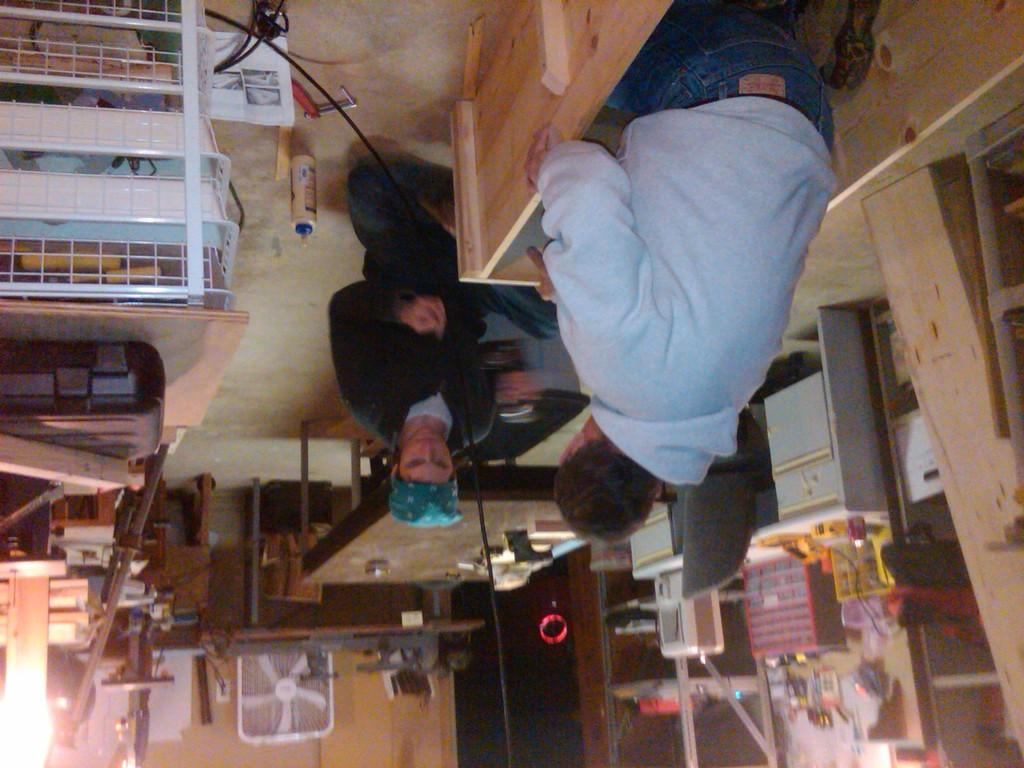How many people are in the image? There are two persons in the image. What can be seen on the table(s) in the image? There are items on the table(s) in the image. What is the purpose of the fan in the image? The fan is likely used for cooling or ventilation in the image. What is the bottle in the image used for? The bottle in the image could be used for holding a beverage or other liquid. Can you describe any other objects present in the image? There are other objects present in the image, but their specific details are not mentioned in the provided facts. What type of chin is visible on the map in the image? There is no map present in the image, and therefore no chin can be observed on it. 